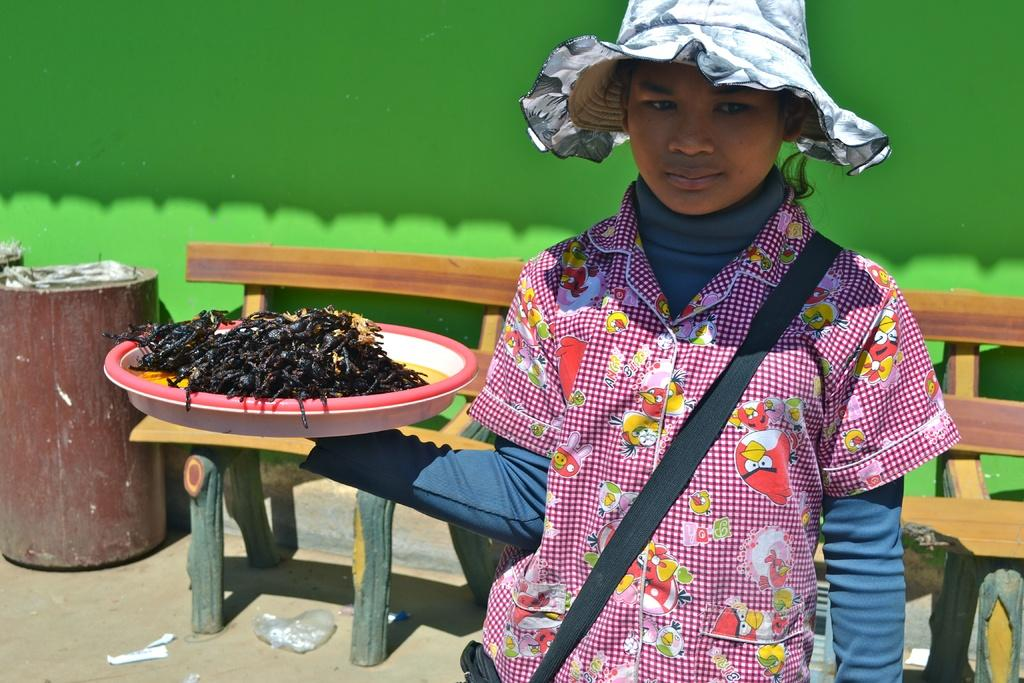What type of clothing accessory is present in the image? There is a cap in the image. What is the person holding in the image? The person is holding a plate with food items in the image. What type of seating is visible in the image? There is a bench in the image. What is covering the objects in the image? There is a plastic cover in the image. What can be seen in the background of the image? There is a green wall in the background of the image. What is the son of the minister doing in the image? There is no son or minister present in the image. Can you describe the person's tongue in the image? There is no reference to a person's tongue in the image. 